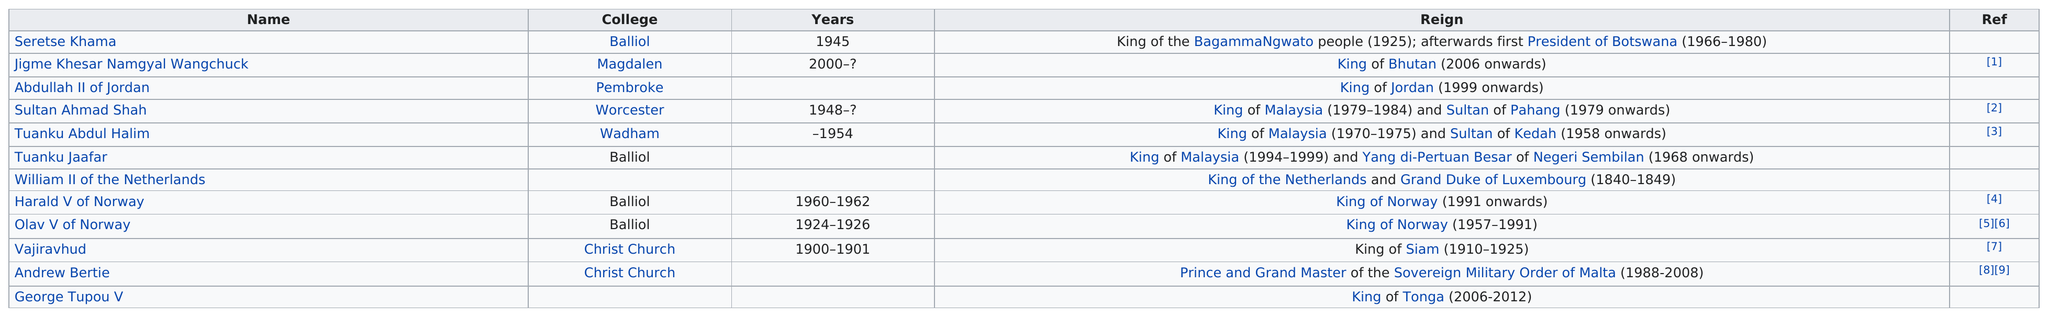Draw attention to some important aspects in this diagram. Before William II of the Netherlands, the monarch was Tuanku Jaafar. Harald V of Norway was the king of Norway for a period of two years while he attended the University of Oxford. Tuanku Jaafar, Harald V of Norway, and Olav V of Norway, all attended the same college at the University of Oxford as Seretse Khama, who was the king of Bechuanaland (modern-day Botswana) from 1951 to 1980. Seretse Khama, the president of Botswana, previously reigned as the leader of BagammaNgwato. Vajiravhud attended college at Christ Church, where he was joined by Andrew Bertie, the other monarch who also attended the institution. 